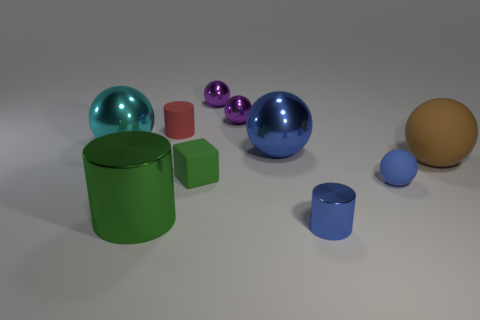There is a large brown object that is the same shape as the big cyan object; what material is it?
Keep it short and to the point. Rubber. Is the material of the green thing left of the tiny cube the same as the brown sphere?
Your answer should be very brief. No. Are there more red matte things that are left of the big cyan shiny object than large brown balls that are in front of the brown rubber object?
Your answer should be compact. No. The red thing is what size?
Your response must be concise. Small. The tiny blue object that is the same material as the green cylinder is what shape?
Make the answer very short. Cylinder. There is a small rubber object behind the big cyan object; is its shape the same as the small blue metal thing?
Your response must be concise. Yes. How many objects are tiny blue matte cubes or purple objects?
Give a very brief answer. 2. What is the material of the cylinder that is both on the right side of the green cylinder and in front of the big cyan thing?
Your response must be concise. Metal. Is the blue shiny cylinder the same size as the matte cylinder?
Provide a succinct answer. Yes. There is a metallic cylinder in front of the big metallic thing that is in front of the small green cube; how big is it?
Your answer should be compact. Small. 